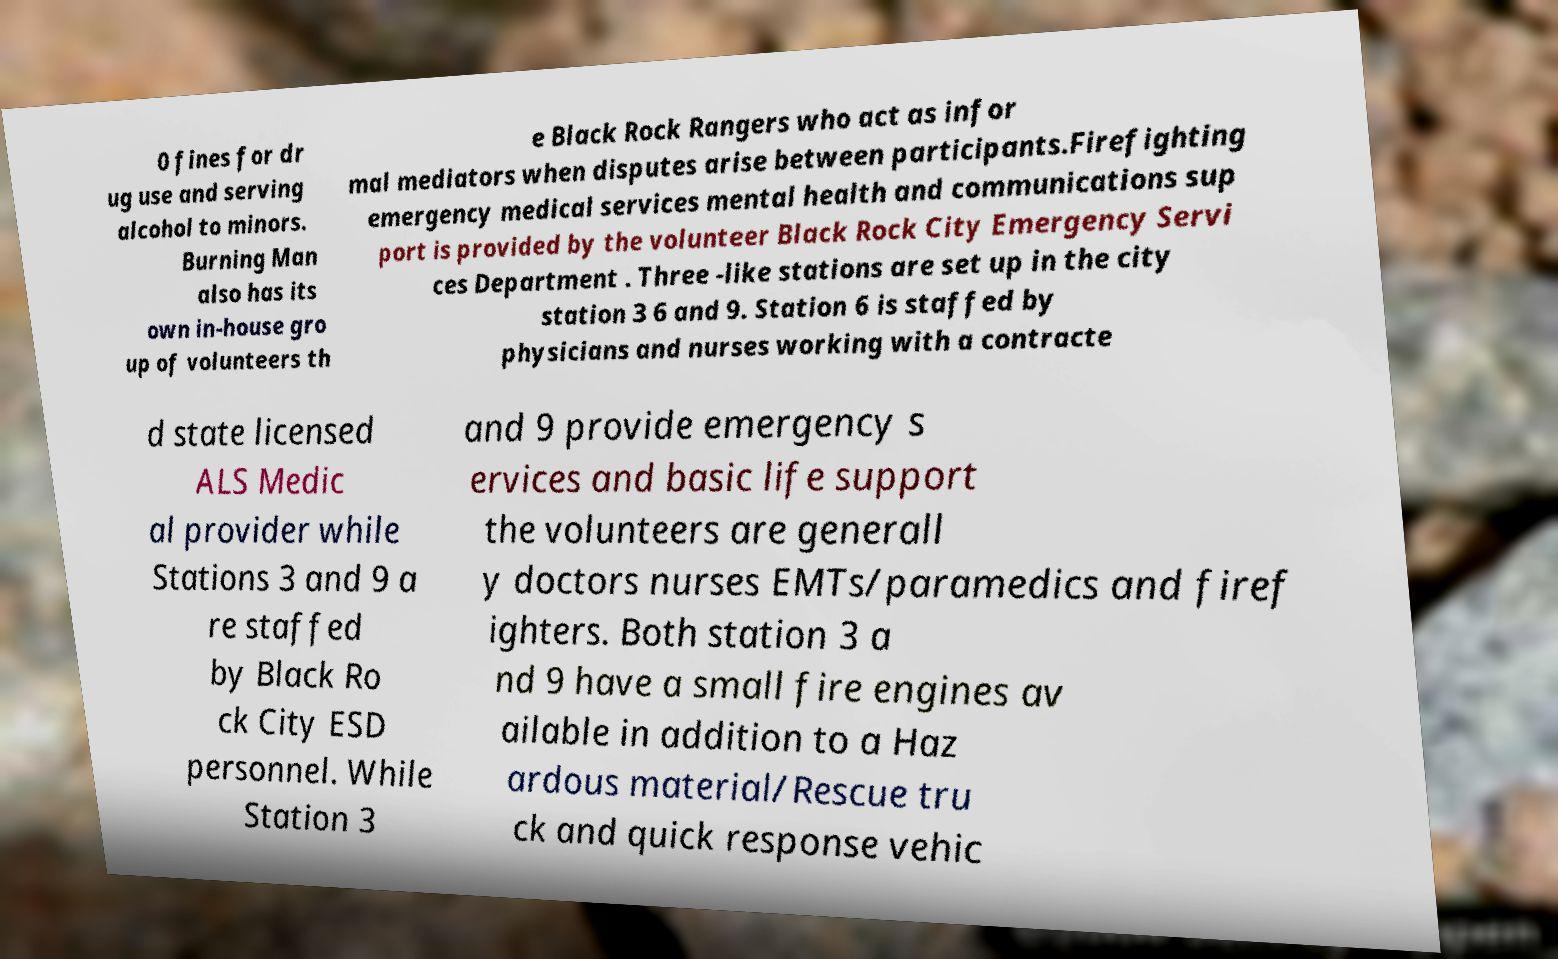Could you assist in decoding the text presented in this image and type it out clearly? 0 fines for dr ug use and serving alcohol to minors. Burning Man also has its own in-house gro up of volunteers th e Black Rock Rangers who act as infor mal mediators when disputes arise between participants.Firefighting emergency medical services mental health and communications sup port is provided by the volunteer Black Rock City Emergency Servi ces Department . Three -like stations are set up in the city station 3 6 and 9. Station 6 is staffed by physicians and nurses working with a contracte d state licensed ALS Medic al provider while Stations 3 and 9 a re staffed by Black Ro ck City ESD personnel. While Station 3 and 9 provide emergency s ervices and basic life support the volunteers are generall y doctors nurses EMTs/paramedics and firef ighters. Both station 3 a nd 9 have a small fire engines av ailable in addition to a Haz ardous material/Rescue tru ck and quick response vehic 